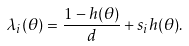<formula> <loc_0><loc_0><loc_500><loc_500>\lambda _ { i } ( \theta ) = \frac { 1 - h ( \theta ) } { d } + s _ { i } h ( \theta ) .</formula> 